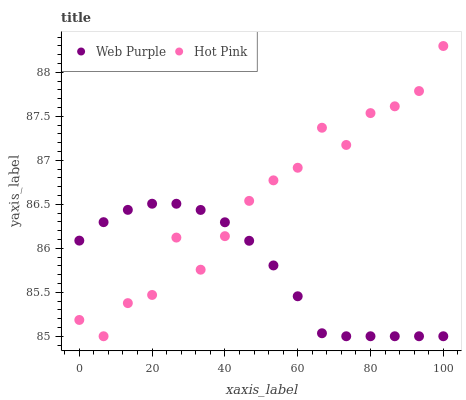Does Web Purple have the minimum area under the curve?
Answer yes or no. Yes. Does Hot Pink have the maximum area under the curve?
Answer yes or no. Yes. Does Hot Pink have the minimum area under the curve?
Answer yes or no. No. Is Web Purple the smoothest?
Answer yes or no. Yes. Is Hot Pink the roughest?
Answer yes or no. Yes. Is Hot Pink the smoothest?
Answer yes or no. No. Does Web Purple have the lowest value?
Answer yes or no. Yes. Does Hot Pink have the highest value?
Answer yes or no. Yes. Does Hot Pink intersect Web Purple?
Answer yes or no. Yes. Is Hot Pink less than Web Purple?
Answer yes or no. No. Is Hot Pink greater than Web Purple?
Answer yes or no. No. 